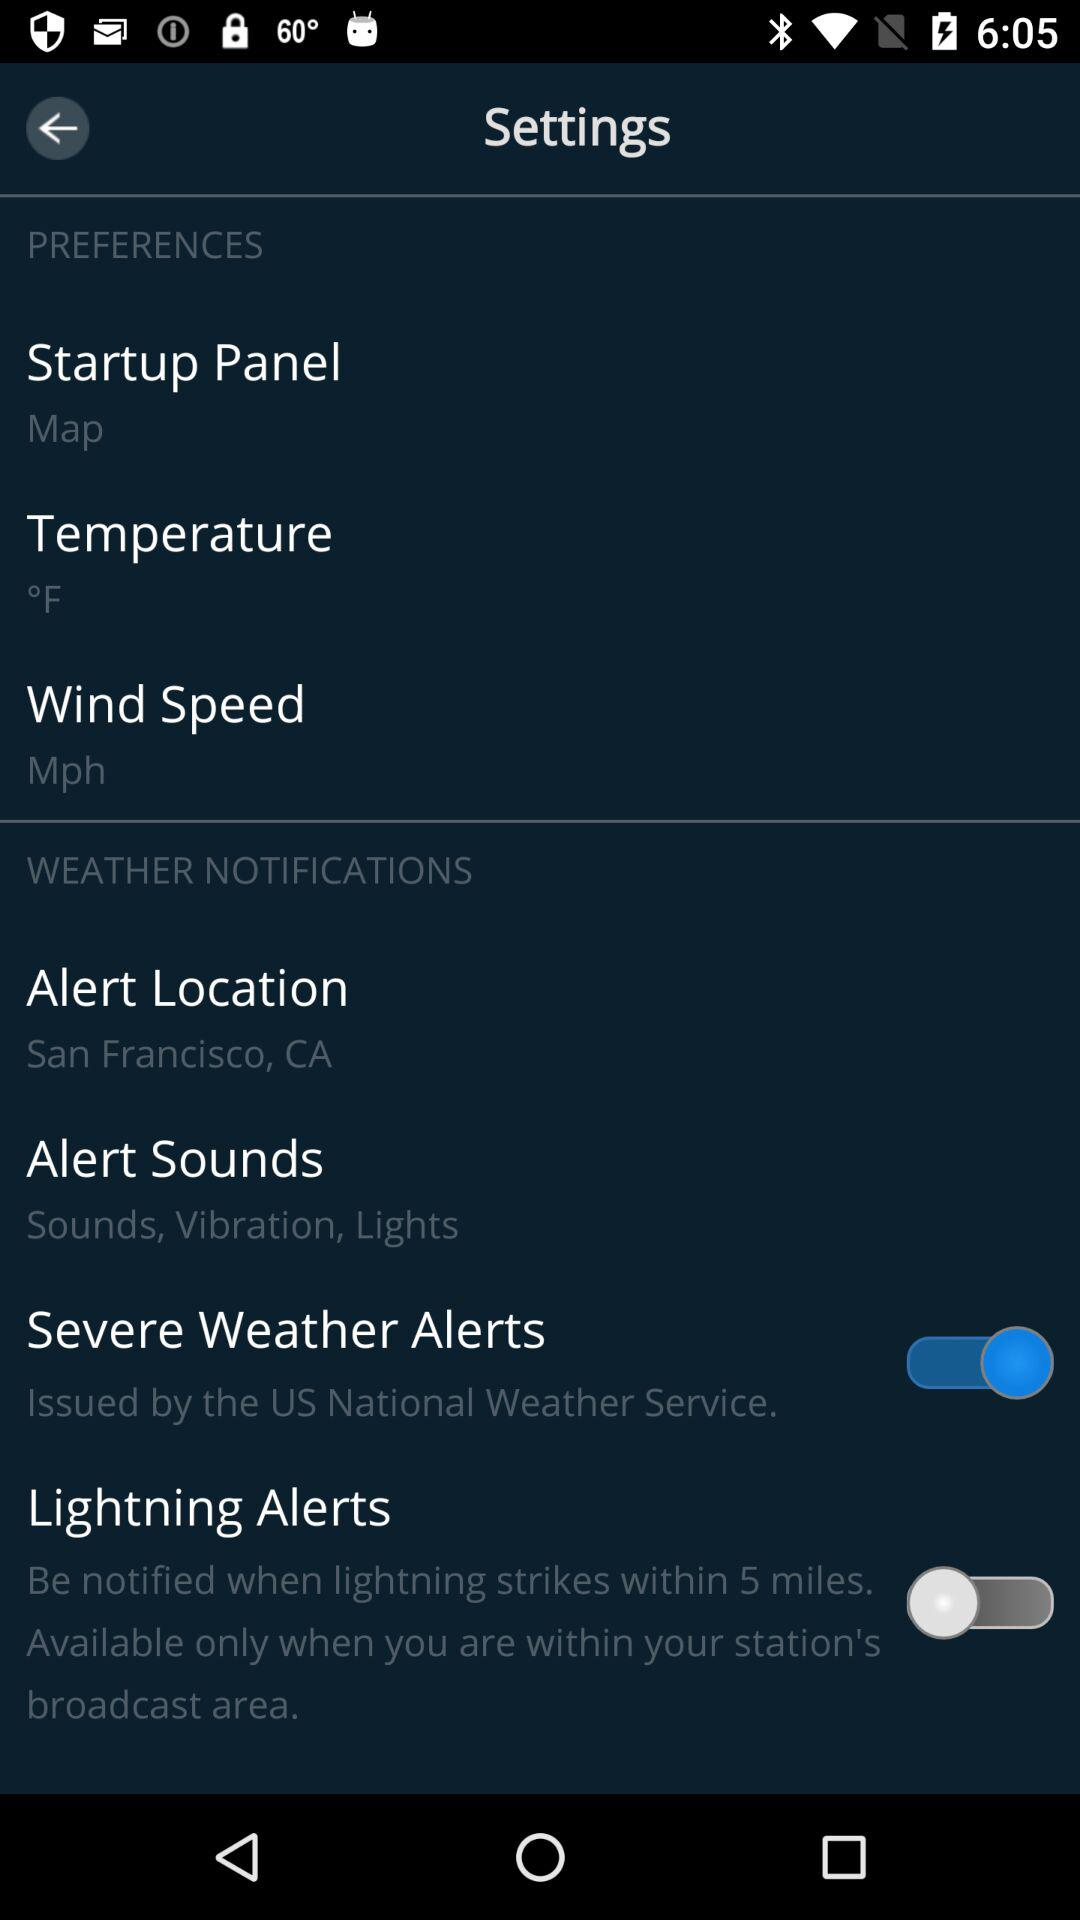What is the status of "Severe Weather Alerts"? The status is "on". 